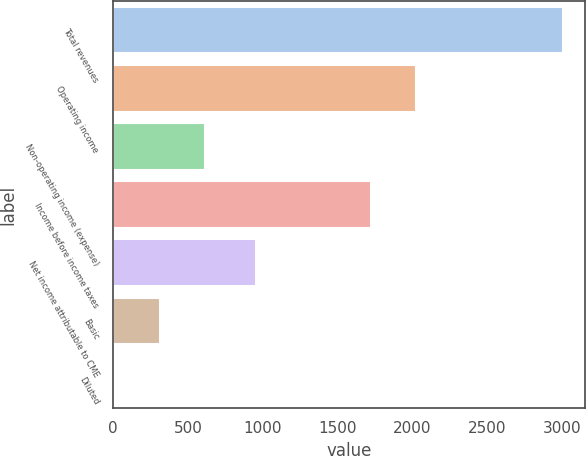<chart> <loc_0><loc_0><loc_500><loc_500><bar_chart><fcel>Total revenues<fcel>Operating income<fcel>Non-operating income (expense)<fcel>Income before income taxes<fcel>Net income attributable to CME<fcel>Basic<fcel>Diluted<nl><fcel>3003.7<fcel>2020.84<fcel>612.19<fcel>1721.9<fcel>951.4<fcel>313.25<fcel>14.31<nl></chart> 